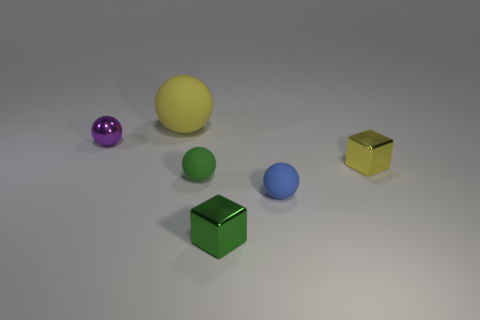Add 2 small objects. How many objects exist? 8 Subtract all spheres. How many objects are left? 2 Add 3 blue balls. How many blue balls are left? 4 Add 4 tiny blue matte spheres. How many tiny blue matte spheres exist? 5 Subtract 0 blue cylinders. How many objects are left? 6 Subtract all yellow objects. Subtract all green matte balls. How many objects are left? 3 